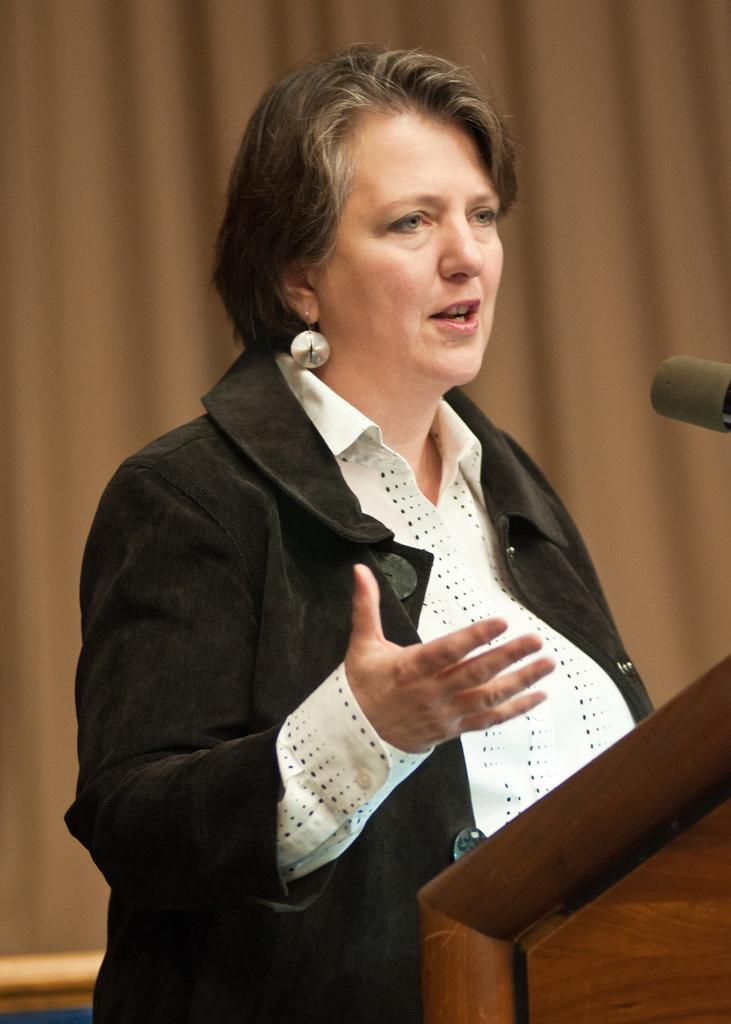Who is the main subject in the image? There is a woman in the image. What is the woman doing in the image? The woman is standing near a podium and speaking. What is on the podium that might be used for amplifying her voice? There is a mic on the podium. What can be seen in the background of the image? There is a curtain in the background of the image. What type of texture can be seen on the leaf in the image? There is no leaf present in the image. What is the woman holding in the image? The woman is not holding a bag or any other object in the image. 